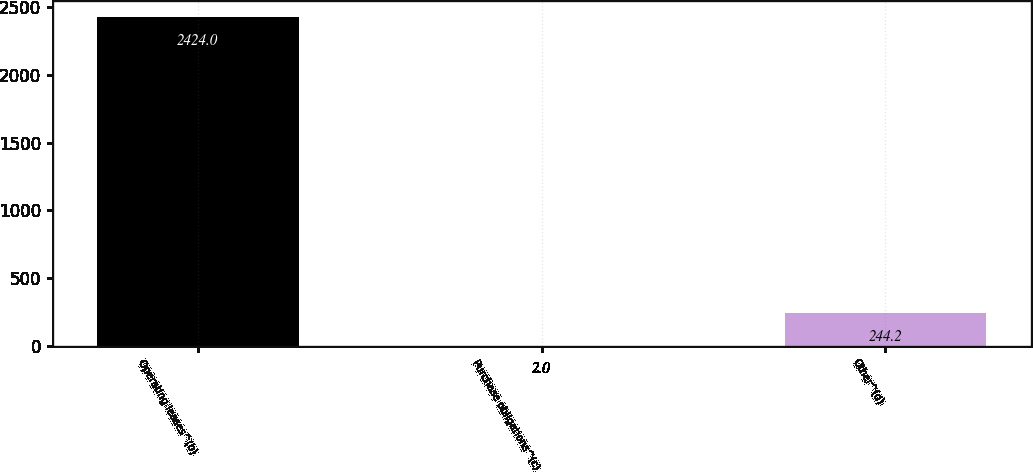Convert chart. <chart><loc_0><loc_0><loc_500><loc_500><bar_chart><fcel>Operating leases^(b)<fcel>Purchase obligations^(c)<fcel>Other^(d)<nl><fcel>2424<fcel>2<fcel>244.2<nl></chart> 